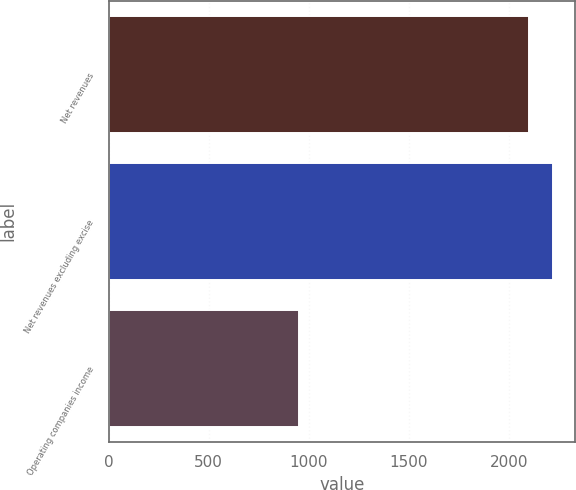<chart> <loc_0><loc_0><loc_500><loc_500><bar_chart><fcel>Net revenues<fcel>Net revenues excluding excise<fcel>Operating companies income<nl><fcel>2104<fcel>2219.6<fcel>953<nl></chart> 